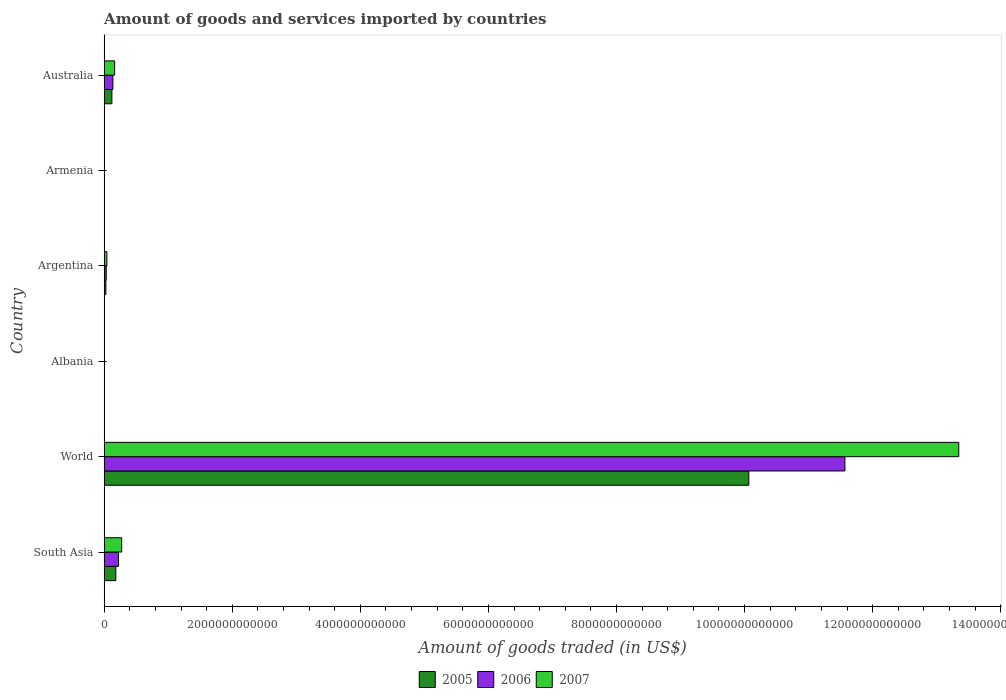How many different coloured bars are there?
Make the answer very short. 3. How many groups of bars are there?
Give a very brief answer. 6. Are the number of bars per tick equal to the number of legend labels?
Provide a short and direct response. Yes. Are the number of bars on each tick of the Y-axis equal?
Offer a terse response. Yes. How many bars are there on the 1st tick from the bottom?
Ensure brevity in your answer.  3. What is the label of the 2nd group of bars from the top?
Make the answer very short. Armenia. What is the total amount of goods and services imported in 2005 in Albania?
Your answer should be very brief. 2.12e+09. Across all countries, what is the maximum total amount of goods and services imported in 2007?
Give a very brief answer. 1.33e+13. Across all countries, what is the minimum total amount of goods and services imported in 2005?
Offer a terse response. 1.66e+09. In which country was the total amount of goods and services imported in 2007 maximum?
Your answer should be very brief. World. In which country was the total amount of goods and services imported in 2005 minimum?
Ensure brevity in your answer.  Armenia. What is the total total amount of goods and services imported in 2005 in the graph?
Your answer should be compact. 1.04e+13. What is the difference between the total amount of goods and services imported in 2005 in Australia and that in World?
Give a very brief answer. -9.94e+12. What is the difference between the total amount of goods and services imported in 2005 in Argentina and the total amount of goods and services imported in 2007 in Armenia?
Ensure brevity in your answer.  2.44e+1. What is the average total amount of goods and services imported in 2006 per country?
Your answer should be compact. 1.99e+12. What is the difference between the total amount of goods and services imported in 2006 and total amount of goods and services imported in 2007 in World?
Your answer should be very brief. -1.78e+12. What is the ratio of the total amount of goods and services imported in 2007 in Argentina to that in South Asia?
Your response must be concise. 0.16. Is the total amount of goods and services imported in 2007 in Argentina less than that in Australia?
Offer a very short reply. Yes. Is the difference between the total amount of goods and services imported in 2006 in South Asia and World greater than the difference between the total amount of goods and services imported in 2007 in South Asia and World?
Your response must be concise. Yes. What is the difference between the highest and the second highest total amount of goods and services imported in 2006?
Your answer should be compact. 1.13e+13. What is the difference between the highest and the lowest total amount of goods and services imported in 2005?
Keep it short and to the point. 1.01e+13. In how many countries, is the total amount of goods and services imported in 2005 greater than the average total amount of goods and services imported in 2005 taken over all countries?
Make the answer very short. 1. What does the 2nd bar from the bottom in World represents?
Provide a succinct answer. 2006. Are all the bars in the graph horizontal?
Give a very brief answer. Yes. How many countries are there in the graph?
Ensure brevity in your answer.  6. What is the difference between two consecutive major ticks on the X-axis?
Offer a terse response. 2.00e+12. Does the graph contain grids?
Give a very brief answer. No. Where does the legend appear in the graph?
Your answer should be compact. Bottom center. How are the legend labels stacked?
Offer a terse response. Horizontal. What is the title of the graph?
Provide a short and direct response. Amount of goods and services imported by countries. Does "1985" appear as one of the legend labels in the graph?
Offer a very short reply. No. What is the label or title of the X-axis?
Ensure brevity in your answer.  Amount of goods traded (in US$). What is the label or title of the Y-axis?
Your response must be concise. Country. What is the Amount of goods traded (in US$) in 2005 in South Asia?
Your answer should be compact. 1.83e+11. What is the Amount of goods traded (in US$) of 2006 in South Asia?
Provide a succinct answer. 2.24e+11. What is the Amount of goods traded (in US$) in 2007 in South Asia?
Your answer should be very brief. 2.74e+11. What is the Amount of goods traded (in US$) in 2005 in World?
Your answer should be very brief. 1.01e+13. What is the Amount of goods traded (in US$) in 2006 in World?
Give a very brief answer. 1.16e+13. What is the Amount of goods traded (in US$) of 2007 in World?
Your answer should be very brief. 1.33e+13. What is the Amount of goods traded (in US$) in 2005 in Albania?
Keep it short and to the point. 2.12e+09. What is the Amount of goods traded (in US$) of 2006 in Albania?
Your response must be concise. 2.50e+09. What is the Amount of goods traded (in US$) of 2007 in Albania?
Provide a short and direct response. 3.42e+09. What is the Amount of goods traded (in US$) in 2005 in Argentina?
Keep it short and to the point. 2.73e+1. What is the Amount of goods traded (in US$) of 2006 in Argentina?
Keep it short and to the point. 3.26e+1. What is the Amount of goods traded (in US$) of 2007 in Argentina?
Provide a short and direct response. 4.25e+1. What is the Amount of goods traded (in US$) in 2005 in Armenia?
Make the answer very short. 1.66e+09. What is the Amount of goods traded (in US$) of 2006 in Armenia?
Keep it short and to the point. 2.00e+09. What is the Amount of goods traded (in US$) in 2007 in Armenia?
Give a very brief answer. 2.92e+09. What is the Amount of goods traded (in US$) of 2005 in Australia?
Your response must be concise. 1.21e+11. What is the Amount of goods traded (in US$) of 2006 in Australia?
Your answer should be very brief. 1.37e+11. What is the Amount of goods traded (in US$) of 2007 in Australia?
Your answer should be very brief. 1.64e+11. Across all countries, what is the maximum Amount of goods traded (in US$) of 2005?
Give a very brief answer. 1.01e+13. Across all countries, what is the maximum Amount of goods traded (in US$) in 2006?
Provide a succinct answer. 1.16e+13. Across all countries, what is the maximum Amount of goods traded (in US$) in 2007?
Your answer should be very brief. 1.33e+13. Across all countries, what is the minimum Amount of goods traded (in US$) in 2005?
Make the answer very short. 1.66e+09. Across all countries, what is the minimum Amount of goods traded (in US$) of 2006?
Provide a short and direct response. 2.00e+09. Across all countries, what is the minimum Amount of goods traded (in US$) in 2007?
Give a very brief answer. 2.92e+09. What is the total Amount of goods traded (in US$) in 2005 in the graph?
Provide a succinct answer. 1.04e+13. What is the total Amount of goods traded (in US$) of 2006 in the graph?
Your answer should be compact. 1.20e+13. What is the total Amount of goods traded (in US$) of 2007 in the graph?
Provide a short and direct response. 1.38e+13. What is the difference between the Amount of goods traded (in US$) of 2005 in South Asia and that in World?
Offer a very short reply. -9.88e+12. What is the difference between the Amount of goods traded (in US$) in 2006 in South Asia and that in World?
Keep it short and to the point. -1.13e+13. What is the difference between the Amount of goods traded (in US$) in 2007 in South Asia and that in World?
Provide a succinct answer. -1.31e+13. What is the difference between the Amount of goods traded (in US$) in 2005 in South Asia and that in Albania?
Ensure brevity in your answer.  1.81e+11. What is the difference between the Amount of goods traded (in US$) in 2006 in South Asia and that in Albania?
Give a very brief answer. 2.21e+11. What is the difference between the Amount of goods traded (in US$) in 2007 in South Asia and that in Albania?
Offer a very short reply. 2.70e+11. What is the difference between the Amount of goods traded (in US$) in 2005 in South Asia and that in Argentina?
Your response must be concise. 1.55e+11. What is the difference between the Amount of goods traded (in US$) of 2006 in South Asia and that in Argentina?
Provide a succinct answer. 1.91e+11. What is the difference between the Amount of goods traded (in US$) of 2007 in South Asia and that in Argentina?
Give a very brief answer. 2.31e+11. What is the difference between the Amount of goods traded (in US$) in 2005 in South Asia and that in Armenia?
Offer a terse response. 1.81e+11. What is the difference between the Amount of goods traded (in US$) in 2006 in South Asia and that in Armenia?
Make the answer very short. 2.22e+11. What is the difference between the Amount of goods traded (in US$) in 2007 in South Asia and that in Armenia?
Provide a succinct answer. 2.71e+11. What is the difference between the Amount of goods traded (in US$) of 2005 in South Asia and that in Australia?
Your answer should be very brief. 6.15e+1. What is the difference between the Amount of goods traded (in US$) of 2006 in South Asia and that in Australia?
Your answer should be compact. 8.69e+1. What is the difference between the Amount of goods traded (in US$) of 2007 in South Asia and that in Australia?
Offer a terse response. 1.10e+11. What is the difference between the Amount of goods traded (in US$) in 2005 in World and that in Albania?
Ensure brevity in your answer.  1.01e+13. What is the difference between the Amount of goods traded (in US$) of 2006 in World and that in Albania?
Ensure brevity in your answer.  1.16e+13. What is the difference between the Amount of goods traded (in US$) in 2007 in World and that in Albania?
Keep it short and to the point. 1.33e+13. What is the difference between the Amount of goods traded (in US$) of 2005 in World and that in Argentina?
Offer a very short reply. 1.00e+13. What is the difference between the Amount of goods traded (in US$) in 2006 in World and that in Argentina?
Make the answer very short. 1.15e+13. What is the difference between the Amount of goods traded (in US$) in 2007 in World and that in Argentina?
Offer a very short reply. 1.33e+13. What is the difference between the Amount of goods traded (in US$) of 2005 in World and that in Armenia?
Provide a short and direct response. 1.01e+13. What is the difference between the Amount of goods traded (in US$) of 2006 in World and that in Armenia?
Your response must be concise. 1.16e+13. What is the difference between the Amount of goods traded (in US$) in 2007 in World and that in Armenia?
Your response must be concise. 1.33e+13. What is the difference between the Amount of goods traded (in US$) in 2005 in World and that in Australia?
Ensure brevity in your answer.  9.94e+12. What is the difference between the Amount of goods traded (in US$) of 2006 in World and that in Australia?
Ensure brevity in your answer.  1.14e+13. What is the difference between the Amount of goods traded (in US$) in 2007 in World and that in Australia?
Provide a succinct answer. 1.32e+13. What is the difference between the Amount of goods traded (in US$) in 2005 in Albania and that in Argentina?
Your answer should be compact. -2.52e+1. What is the difference between the Amount of goods traded (in US$) in 2006 in Albania and that in Argentina?
Make the answer very short. -3.01e+1. What is the difference between the Amount of goods traded (in US$) in 2007 in Albania and that in Argentina?
Make the answer very short. -3.91e+1. What is the difference between the Amount of goods traded (in US$) in 2005 in Albania and that in Armenia?
Your answer should be very brief. 4.54e+08. What is the difference between the Amount of goods traded (in US$) of 2006 in Albania and that in Armenia?
Your answer should be very brief. 5.00e+08. What is the difference between the Amount of goods traded (in US$) in 2007 in Albania and that in Armenia?
Offer a very short reply. 4.99e+08. What is the difference between the Amount of goods traded (in US$) of 2005 in Albania and that in Australia?
Provide a short and direct response. -1.19e+11. What is the difference between the Amount of goods traded (in US$) in 2006 in Albania and that in Australia?
Your response must be concise. -1.34e+11. What is the difference between the Amount of goods traded (in US$) in 2007 in Albania and that in Australia?
Offer a very short reply. -1.60e+11. What is the difference between the Amount of goods traded (in US$) in 2005 in Argentina and that in Armenia?
Offer a terse response. 2.56e+1. What is the difference between the Amount of goods traded (in US$) in 2006 in Argentina and that in Armenia?
Give a very brief answer. 3.06e+1. What is the difference between the Amount of goods traded (in US$) in 2007 in Argentina and that in Armenia?
Make the answer very short. 3.96e+1. What is the difference between the Amount of goods traded (in US$) of 2005 in Argentina and that in Australia?
Provide a short and direct response. -9.39e+1. What is the difference between the Amount of goods traded (in US$) in 2006 in Argentina and that in Australia?
Give a very brief answer. -1.04e+11. What is the difference between the Amount of goods traded (in US$) of 2007 in Argentina and that in Australia?
Your response must be concise. -1.21e+11. What is the difference between the Amount of goods traded (in US$) in 2005 in Armenia and that in Australia?
Ensure brevity in your answer.  -1.20e+11. What is the difference between the Amount of goods traded (in US$) of 2006 in Armenia and that in Australia?
Ensure brevity in your answer.  -1.35e+11. What is the difference between the Amount of goods traded (in US$) of 2007 in Armenia and that in Australia?
Your answer should be compact. -1.61e+11. What is the difference between the Amount of goods traded (in US$) of 2005 in South Asia and the Amount of goods traded (in US$) of 2006 in World?
Provide a short and direct response. -1.14e+13. What is the difference between the Amount of goods traded (in US$) in 2005 in South Asia and the Amount of goods traded (in US$) in 2007 in World?
Your answer should be very brief. -1.32e+13. What is the difference between the Amount of goods traded (in US$) of 2006 in South Asia and the Amount of goods traded (in US$) of 2007 in World?
Offer a terse response. -1.31e+13. What is the difference between the Amount of goods traded (in US$) of 2005 in South Asia and the Amount of goods traded (in US$) of 2006 in Albania?
Your response must be concise. 1.80e+11. What is the difference between the Amount of goods traded (in US$) in 2005 in South Asia and the Amount of goods traded (in US$) in 2007 in Albania?
Your answer should be compact. 1.79e+11. What is the difference between the Amount of goods traded (in US$) of 2006 in South Asia and the Amount of goods traded (in US$) of 2007 in Albania?
Your answer should be very brief. 2.20e+11. What is the difference between the Amount of goods traded (in US$) in 2005 in South Asia and the Amount of goods traded (in US$) in 2006 in Argentina?
Ensure brevity in your answer.  1.50e+11. What is the difference between the Amount of goods traded (in US$) of 2005 in South Asia and the Amount of goods traded (in US$) of 2007 in Argentina?
Your answer should be very brief. 1.40e+11. What is the difference between the Amount of goods traded (in US$) of 2006 in South Asia and the Amount of goods traded (in US$) of 2007 in Argentina?
Your response must be concise. 1.81e+11. What is the difference between the Amount of goods traded (in US$) in 2005 in South Asia and the Amount of goods traded (in US$) in 2006 in Armenia?
Make the answer very short. 1.81e+11. What is the difference between the Amount of goods traded (in US$) in 2005 in South Asia and the Amount of goods traded (in US$) in 2007 in Armenia?
Offer a very short reply. 1.80e+11. What is the difference between the Amount of goods traded (in US$) of 2006 in South Asia and the Amount of goods traded (in US$) of 2007 in Armenia?
Keep it short and to the point. 2.21e+11. What is the difference between the Amount of goods traded (in US$) of 2005 in South Asia and the Amount of goods traded (in US$) of 2006 in Australia?
Your response must be concise. 4.59e+1. What is the difference between the Amount of goods traded (in US$) in 2005 in South Asia and the Amount of goods traded (in US$) in 2007 in Australia?
Your response must be concise. 1.90e+1. What is the difference between the Amount of goods traded (in US$) of 2006 in South Asia and the Amount of goods traded (in US$) of 2007 in Australia?
Give a very brief answer. 6.00e+1. What is the difference between the Amount of goods traded (in US$) in 2005 in World and the Amount of goods traded (in US$) in 2006 in Albania?
Give a very brief answer. 1.01e+13. What is the difference between the Amount of goods traded (in US$) of 2005 in World and the Amount of goods traded (in US$) of 2007 in Albania?
Keep it short and to the point. 1.01e+13. What is the difference between the Amount of goods traded (in US$) in 2006 in World and the Amount of goods traded (in US$) in 2007 in Albania?
Provide a short and direct response. 1.16e+13. What is the difference between the Amount of goods traded (in US$) in 2005 in World and the Amount of goods traded (in US$) in 2006 in Argentina?
Provide a succinct answer. 1.00e+13. What is the difference between the Amount of goods traded (in US$) in 2005 in World and the Amount of goods traded (in US$) in 2007 in Argentina?
Your answer should be compact. 1.00e+13. What is the difference between the Amount of goods traded (in US$) in 2006 in World and the Amount of goods traded (in US$) in 2007 in Argentina?
Make the answer very short. 1.15e+13. What is the difference between the Amount of goods traded (in US$) of 2005 in World and the Amount of goods traded (in US$) of 2006 in Armenia?
Ensure brevity in your answer.  1.01e+13. What is the difference between the Amount of goods traded (in US$) in 2005 in World and the Amount of goods traded (in US$) in 2007 in Armenia?
Make the answer very short. 1.01e+13. What is the difference between the Amount of goods traded (in US$) of 2006 in World and the Amount of goods traded (in US$) of 2007 in Armenia?
Provide a short and direct response. 1.16e+13. What is the difference between the Amount of goods traded (in US$) in 2005 in World and the Amount of goods traded (in US$) in 2006 in Australia?
Your response must be concise. 9.93e+12. What is the difference between the Amount of goods traded (in US$) of 2005 in World and the Amount of goods traded (in US$) of 2007 in Australia?
Give a very brief answer. 9.90e+12. What is the difference between the Amount of goods traded (in US$) of 2006 in World and the Amount of goods traded (in US$) of 2007 in Australia?
Ensure brevity in your answer.  1.14e+13. What is the difference between the Amount of goods traded (in US$) in 2005 in Albania and the Amount of goods traded (in US$) in 2006 in Argentina?
Keep it short and to the point. -3.05e+1. What is the difference between the Amount of goods traded (in US$) of 2005 in Albania and the Amount of goods traded (in US$) of 2007 in Argentina?
Offer a very short reply. -4.04e+1. What is the difference between the Amount of goods traded (in US$) in 2006 in Albania and the Amount of goods traded (in US$) in 2007 in Argentina?
Offer a terse response. -4.00e+1. What is the difference between the Amount of goods traded (in US$) of 2005 in Albania and the Amount of goods traded (in US$) of 2006 in Armenia?
Offer a very short reply. 1.18e+08. What is the difference between the Amount of goods traded (in US$) of 2005 in Albania and the Amount of goods traded (in US$) of 2007 in Armenia?
Keep it short and to the point. -8.04e+08. What is the difference between the Amount of goods traded (in US$) in 2006 in Albania and the Amount of goods traded (in US$) in 2007 in Armenia?
Offer a very short reply. -4.21e+08. What is the difference between the Amount of goods traded (in US$) in 2005 in Albania and the Amount of goods traded (in US$) in 2006 in Australia?
Keep it short and to the point. -1.35e+11. What is the difference between the Amount of goods traded (in US$) of 2005 in Albania and the Amount of goods traded (in US$) of 2007 in Australia?
Keep it short and to the point. -1.62e+11. What is the difference between the Amount of goods traded (in US$) of 2006 in Albania and the Amount of goods traded (in US$) of 2007 in Australia?
Offer a very short reply. -1.61e+11. What is the difference between the Amount of goods traded (in US$) in 2005 in Argentina and the Amount of goods traded (in US$) in 2006 in Armenia?
Ensure brevity in your answer.  2.53e+1. What is the difference between the Amount of goods traded (in US$) in 2005 in Argentina and the Amount of goods traded (in US$) in 2007 in Armenia?
Offer a terse response. 2.44e+1. What is the difference between the Amount of goods traded (in US$) in 2006 in Argentina and the Amount of goods traded (in US$) in 2007 in Armenia?
Your answer should be compact. 2.97e+1. What is the difference between the Amount of goods traded (in US$) in 2005 in Argentina and the Amount of goods traded (in US$) in 2006 in Australia?
Make the answer very short. -1.09e+11. What is the difference between the Amount of goods traded (in US$) in 2005 in Argentina and the Amount of goods traded (in US$) in 2007 in Australia?
Offer a terse response. -1.36e+11. What is the difference between the Amount of goods traded (in US$) in 2006 in Argentina and the Amount of goods traded (in US$) in 2007 in Australia?
Offer a terse response. -1.31e+11. What is the difference between the Amount of goods traded (in US$) in 2005 in Armenia and the Amount of goods traded (in US$) in 2006 in Australia?
Your answer should be compact. -1.35e+11. What is the difference between the Amount of goods traded (in US$) in 2005 in Armenia and the Amount of goods traded (in US$) in 2007 in Australia?
Keep it short and to the point. -1.62e+11. What is the difference between the Amount of goods traded (in US$) of 2006 in Armenia and the Amount of goods traded (in US$) of 2007 in Australia?
Ensure brevity in your answer.  -1.62e+11. What is the average Amount of goods traded (in US$) in 2005 per country?
Ensure brevity in your answer.  1.73e+12. What is the average Amount of goods traded (in US$) of 2006 per country?
Give a very brief answer. 1.99e+12. What is the average Amount of goods traded (in US$) in 2007 per country?
Offer a terse response. 2.31e+12. What is the difference between the Amount of goods traded (in US$) in 2005 and Amount of goods traded (in US$) in 2006 in South Asia?
Ensure brevity in your answer.  -4.10e+1. What is the difference between the Amount of goods traded (in US$) of 2005 and Amount of goods traded (in US$) of 2007 in South Asia?
Offer a very short reply. -9.08e+1. What is the difference between the Amount of goods traded (in US$) of 2006 and Amount of goods traded (in US$) of 2007 in South Asia?
Your answer should be very brief. -4.98e+1. What is the difference between the Amount of goods traded (in US$) of 2005 and Amount of goods traded (in US$) of 2006 in World?
Offer a terse response. -1.50e+12. What is the difference between the Amount of goods traded (in US$) of 2005 and Amount of goods traded (in US$) of 2007 in World?
Your answer should be very brief. -3.28e+12. What is the difference between the Amount of goods traded (in US$) in 2006 and Amount of goods traded (in US$) in 2007 in World?
Your answer should be very brief. -1.78e+12. What is the difference between the Amount of goods traded (in US$) in 2005 and Amount of goods traded (in US$) in 2006 in Albania?
Offer a very short reply. -3.82e+08. What is the difference between the Amount of goods traded (in US$) in 2005 and Amount of goods traded (in US$) in 2007 in Albania?
Give a very brief answer. -1.30e+09. What is the difference between the Amount of goods traded (in US$) of 2006 and Amount of goods traded (in US$) of 2007 in Albania?
Make the answer very short. -9.20e+08. What is the difference between the Amount of goods traded (in US$) in 2005 and Amount of goods traded (in US$) in 2006 in Argentina?
Keep it short and to the point. -5.29e+09. What is the difference between the Amount of goods traded (in US$) in 2005 and Amount of goods traded (in US$) in 2007 in Argentina?
Keep it short and to the point. -1.52e+1. What is the difference between the Amount of goods traded (in US$) in 2006 and Amount of goods traded (in US$) in 2007 in Argentina?
Your response must be concise. -9.94e+09. What is the difference between the Amount of goods traded (in US$) of 2005 and Amount of goods traded (in US$) of 2006 in Armenia?
Ensure brevity in your answer.  -3.37e+08. What is the difference between the Amount of goods traded (in US$) in 2005 and Amount of goods traded (in US$) in 2007 in Armenia?
Your answer should be very brief. -1.26e+09. What is the difference between the Amount of goods traded (in US$) in 2006 and Amount of goods traded (in US$) in 2007 in Armenia?
Your answer should be compact. -9.21e+08. What is the difference between the Amount of goods traded (in US$) in 2005 and Amount of goods traded (in US$) in 2006 in Australia?
Provide a succinct answer. -1.56e+1. What is the difference between the Amount of goods traded (in US$) of 2005 and Amount of goods traded (in US$) of 2007 in Australia?
Your answer should be very brief. -4.25e+1. What is the difference between the Amount of goods traded (in US$) in 2006 and Amount of goods traded (in US$) in 2007 in Australia?
Your answer should be compact. -2.69e+1. What is the ratio of the Amount of goods traded (in US$) of 2005 in South Asia to that in World?
Provide a succinct answer. 0.02. What is the ratio of the Amount of goods traded (in US$) of 2006 in South Asia to that in World?
Provide a short and direct response. 0.02. What is the ratio of the Amount of goods traded (in US$) in 2007 in South Asia to that in World?
Ensure brevity in your answer.  0.02. What is the ratio of the Amount of goods traded (in US$) in 2005 in South Asia to that in Albania?
Offer a terse response. 86.28. What is the ratio of the Amount of goods traded (in US$) in 2006 in South Asia to that in Albania?
Your response must be concise. 89.49. What is the ratio of the Amount of goods traded (in US$) in 2007 in South Asia to that in Albania?
Your answer should be very brief. 79.98. What is the ratio of the Amount of goods traded (in US$) in 2005 in South Asia to that in Argentina?
Ensure brevity in your answer.  6.69. What is the ratio of the Amount of goods traded (in US$) of 2006 in South Asia to that in Argentina?
Give a very brief answer. 6.86. What is the ratio of the Amount of goods traded (in US$) in 2007 in South Asia to that in Argentina?
Provide a short and direct response. 6.43. What is the ratio of the Amount of goods traded (in US$) in 2005 in South Asia to that in Armenia?
Your answer should be compact. 109.83. What is the ratio of the Amount of goods traded (in US$) in 2006 in South Asia to that in Armenia?
Provide a short and direct response. 111.86. What is the ratio of the Amount of goods traded (in US$) of 2007 in South Asia to that in Armenia?
Keep it short and to the point. 93.64. What is the ratio of the Amount of goods traded (in US$) of 2005 in South Asia to that in Australia?
Make the answer very short. 1.51. What is the ratio of the Amount of goods traded (in US$) in 2006 in South Asia to that in Australia?
Make the answer very short. 1.64. What is the ratio of the Amount of goods traded (in US$) of 2007 in South Asia to that in Australia?
Offer a terse response. 1.67. What is the ratio of the Amount of goods traded (in US$) in 2005 in World to that in Albania?
Ensure brevity in your answer.  4753.81. What is the ratio of the Amount of goods traded (in US$) in 2006 in World to that in Albania?
Keep it short and to the point. 4627.15. What is the ratio of the Amount of goods traded (in US$) in 2007 in World to that in Albania?
Keep it short and to the point. 3902.19. What is the ratio of the Amount of goods traded (in US$) in 2005 in World to that in Argentina?
Offer a very short reply. 368.72. What is the ratio of the Amount of goods traded (in US$) in 2006 in World to that in Argentina?
Ensure brevity in your answer.  354.94. What is the ratio of the Amount of goods traded (in US$) in 2007 in World to that in Argentina?
Provide a short and direct response. 313.8. What is the ratio of the Amount of goods traded (in US$) in 2005 in World to that in Armenia?
Make the answer very short. 6051.57. What is the ratio of the Amount of goods traded (in US$) in 2006 in World to that in Armenia?
Your response must be concise. 5783.57. What is the ratio of the Amount of goods traded (in US$) of 2007 in World to that in Armenia?
Offer a terse response. 4568.25. What is the ratio of the Amount of goods traded (in US$) of 2005 in World to that in Australia?
Ensure brevity in your answer.  83.05. What is the ratio of the Amount of goods traded (in US$) of 2006 in World to that in Australia?
Offer a very short reply. 84.58. What is the ratio of the Amount of goods traded (in US$) of 2007 in World to that in Australia?
Make the answer very short. 81.53. What is the ratio of the Amount of goods traded (in US$) of 2005 in Albania to that in Argentina?
Offer a terse response. 0.08. What is the ratio of the Amount of goods traded (in US$) in 2006 in Albania to that in Argentina?
Your answer should be very brief. 0.08. What is the ratio of the Amount of goods traded (in US$) in 2007 in Albania to that in Argentina?
Give a very brief answer. 0.08. What is the ratio of the Amount of goods traded (in US$) of 2005 in Albania to that in Armenia?
Your answer should be very brief. 1.27. What is the ratio of the Amount of goods traded (in US$) in 2006 in Albania to that in Armenia?
Your answer should be compact. 1.25. What is the ratio of the Amount of goods traded (in US$) of 2007 in Albania to that in Armenia?
Your answer should be compact. 1.17. What is the ratio of the Amount of goods traded (in US$) in 2005 in Albania to that in Australia?
Offer a very short reply. 0.02. What is the ratio of the Amount of goods traded (in US$) of 2006 in Albania to that in Australia?
Offer a terse response. 0.02. What is the ratio of the Amount of goods traded (in US$) of 2007 in Albania to that in Australia?
Your answer should be very brief. 0.02. What is the ratio of the Amount of goods traded (in US$) in 2005 in Argentina to that in Armenia?
Your response must be concise. 16.41. What is the ratio of the Amount of goods traded (in US$) in 2006 in Argentina to that in Armenia?
Your answer should be compact. 16.29. What is the ratio of the Amount of goods traded (in US$) in 2007 in Argentina to that in Armenia?
Keep it short and to the point. 14.56. What is the ratio of the Amount of goods traded (in US$) in 2005 in Argentina to that in Australia?
Your response must be concise. 0.23. What is the ratio of the Amount of goods traded (in US$) in 2006 in Argentina to that in Australia?
Provide a succinct answer. 0.24. What is the ratio of the Amount of goods traded (in US$) of 2007 in Argentina to that in Australia?
Ensure brevity in your answer.  0.26. What is the ratio of the Amount of goods traded (in US$) of 2005 in Armenia to that in Australia?
Provide a succinct answer. 0.01. What is the ratio of the Amount of goods traded (in US$) of 2006 in Armenia to that in Australia?
Make the answer very short. 0.01. What is the ratio of the Amount of goods traded (in US$) in 2007 in Armenia to that in Australia?
Provide a succinct answer. 0.02. What is the difference between the highest and the second highest Amount of goods traded (in US$) in 2005?
Your answer should be very brief. 9.88e+12. What is the difference between the highest and the second highest Amount of goods traded (in US$) of 2006?
Provide a short and direct response. 1.13e+13. What is the difference between the highest and the second highest Amount of goods traded (in US$) in 2007?
Your answer should be compact. 1.31e+13. What is the difference between the highest and the lowest Amount of goods traded (in US$) in 2005?
Offer a terse response. 1.01e+13. What is the difference between the highest and the lowest Amount of goods traded (in US$) in 2006?
Offer a very short reply. 1.16e+13. What is the difference between the highest and the lowest Amount of goods traded (in US$) in 2007?
Keep it short and to the point. 1.33e+13. 